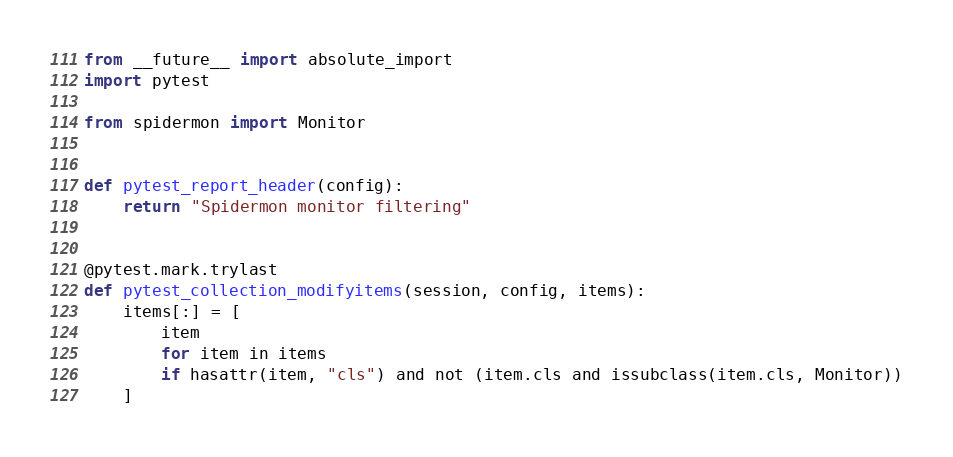<code> <loc_0><loc_0><loc_500><loc_500><_Python_>from __future__ import absolute_import
import pytest

from spidermon import Monitor


def pytest_report_header(config):
    return "Spidermon monitor filtering"


@pytest.mark.trylast
def pytest_collection_modifyitems(session, config, items):
    items[:] = [
        item
        for item in items
        if hasattr(item, "cls") and not (item.cls and issubclass(item.cls, Monitor))
    ]
</code> 